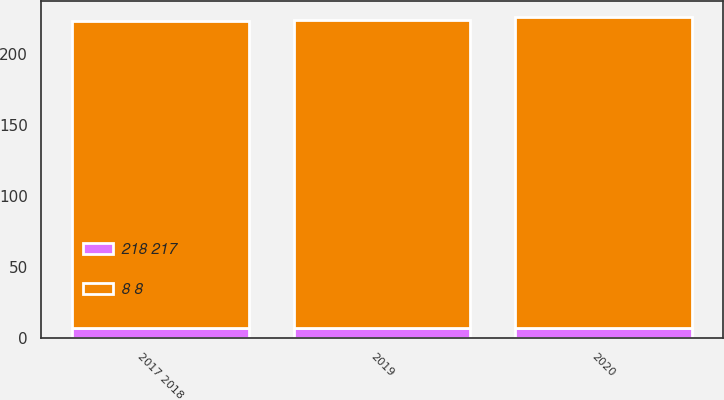<chart> <loc_0><loc_0><loc_500><loc_500><stacked_bar_chart><ecel><fcel>2017 2018<fcel>2019<fcel>2020<nl><fcel>8 8<fcel>216<fcel>217<fcel>219<nl><fcel>218 217<fcel>7<fcel>7<fcel>7<nl></chart> 